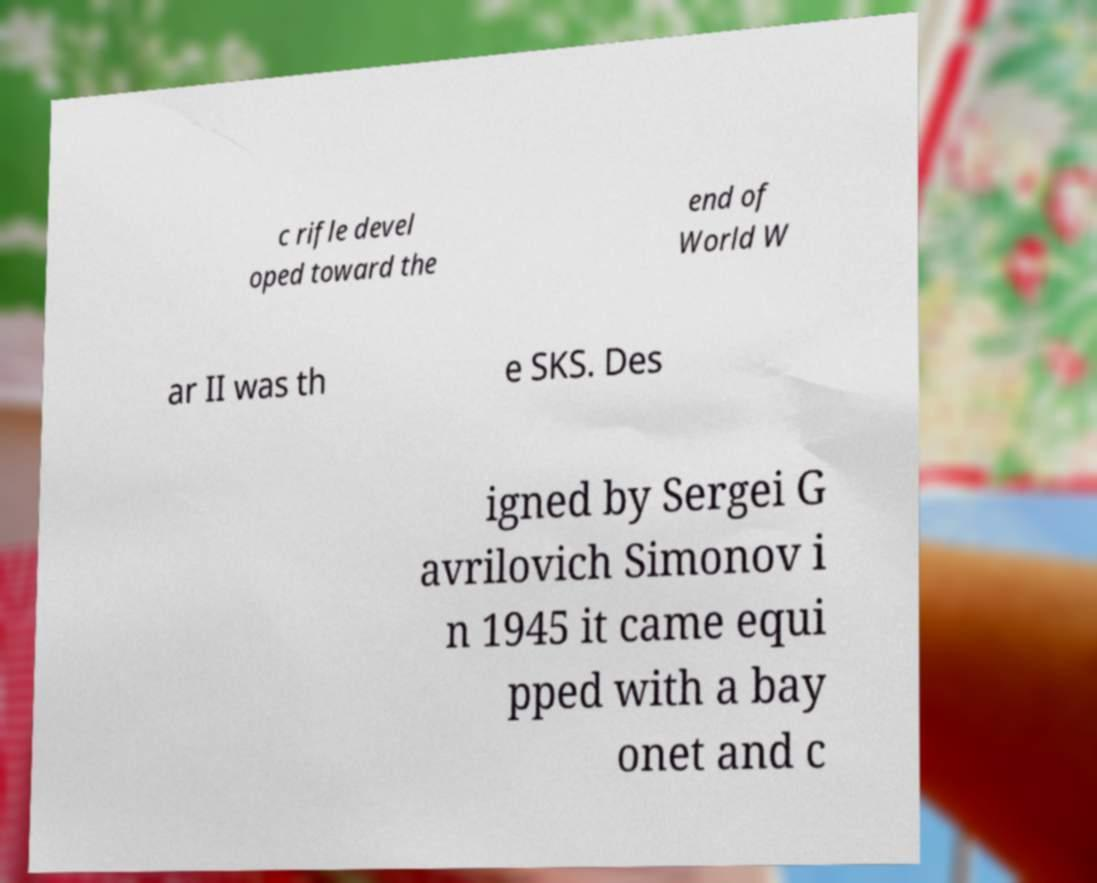Please read and relay the text visible in this image. What does it say? c rifle devel oped toward the end of World W ar II was th e SKS. Des igned by Sergei G avrilovich Simonov i n 1945 it came equi pped with a bay onet and c 